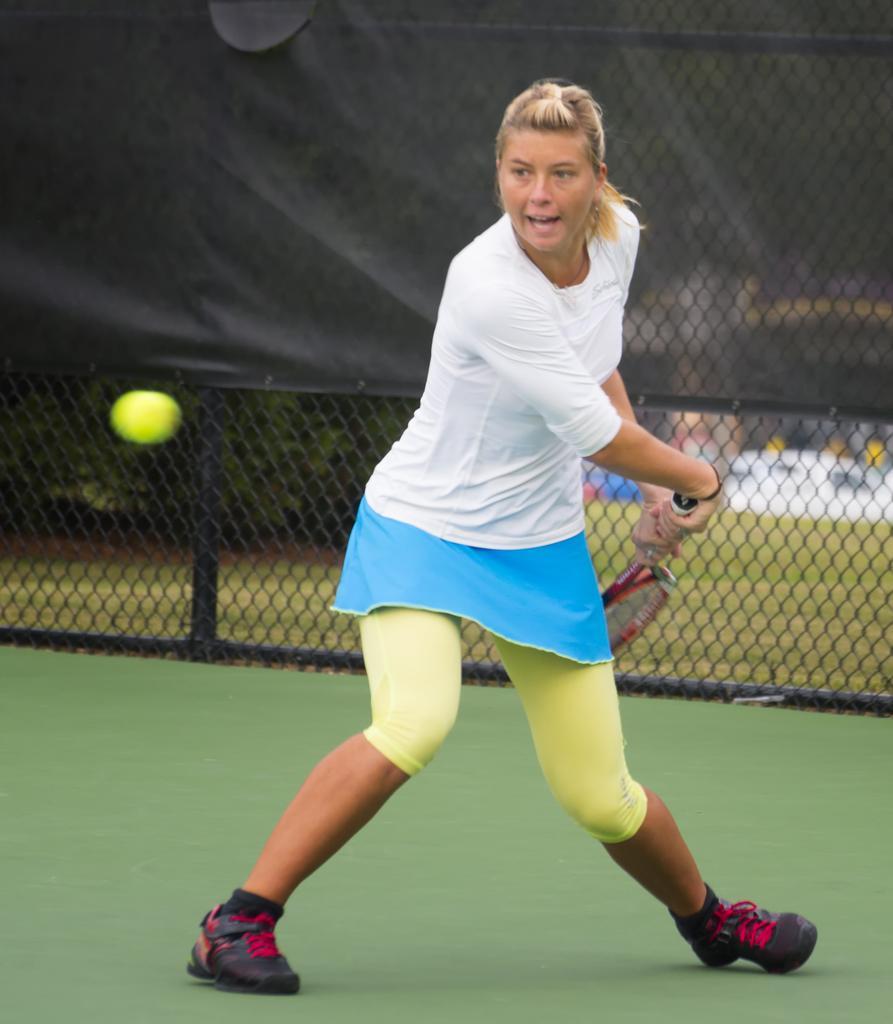Please provide a concise description of this image. On the background we can see a black colour cloth and a net. We can see one woman holding a tennis racket in her hand and playing. This is a play area. This is a ball in green colour. 